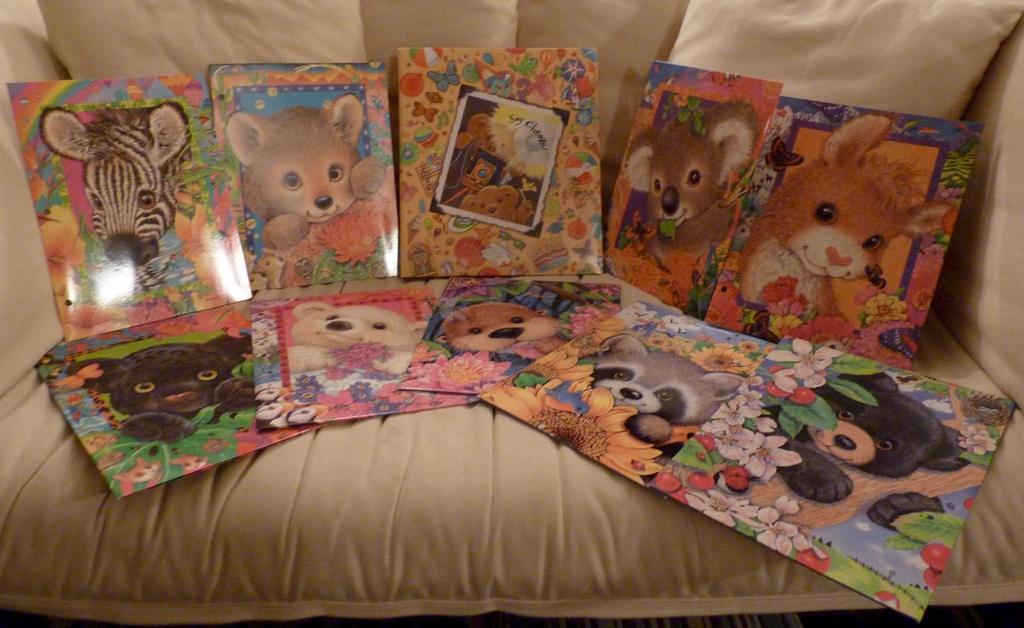What type of furniture is in the image? There is a couch in the image. What is placed on the couch? There are posters and pillows on the couch. How does the couch handle the rainstorm in the image? There is no rainstorm present in the image, so the couch is not handling any rain. 